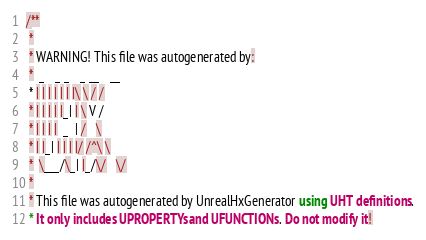<code> <loc_0><loc_0><loc_500><loc_500><_Haxe_>/**
 * 
 * WARNING! This file was autogenerated by: 
 *  _   _ _   _ __   __ 
 * | | | | | | |\ \ / / 
 * | | | | |_| | \ V /  
 * | | | |  _  | /   \  
 * | |_| | | | |/ /^\ \ 
 *  \___/\_| |_/\/   \/ 
 * 
 * This file was autogenerated by UnrealHxGenerator using UHT definitions.
 * It only includes UPROPERTYs and UFUNCTIONs. Do not modify it!</code> 